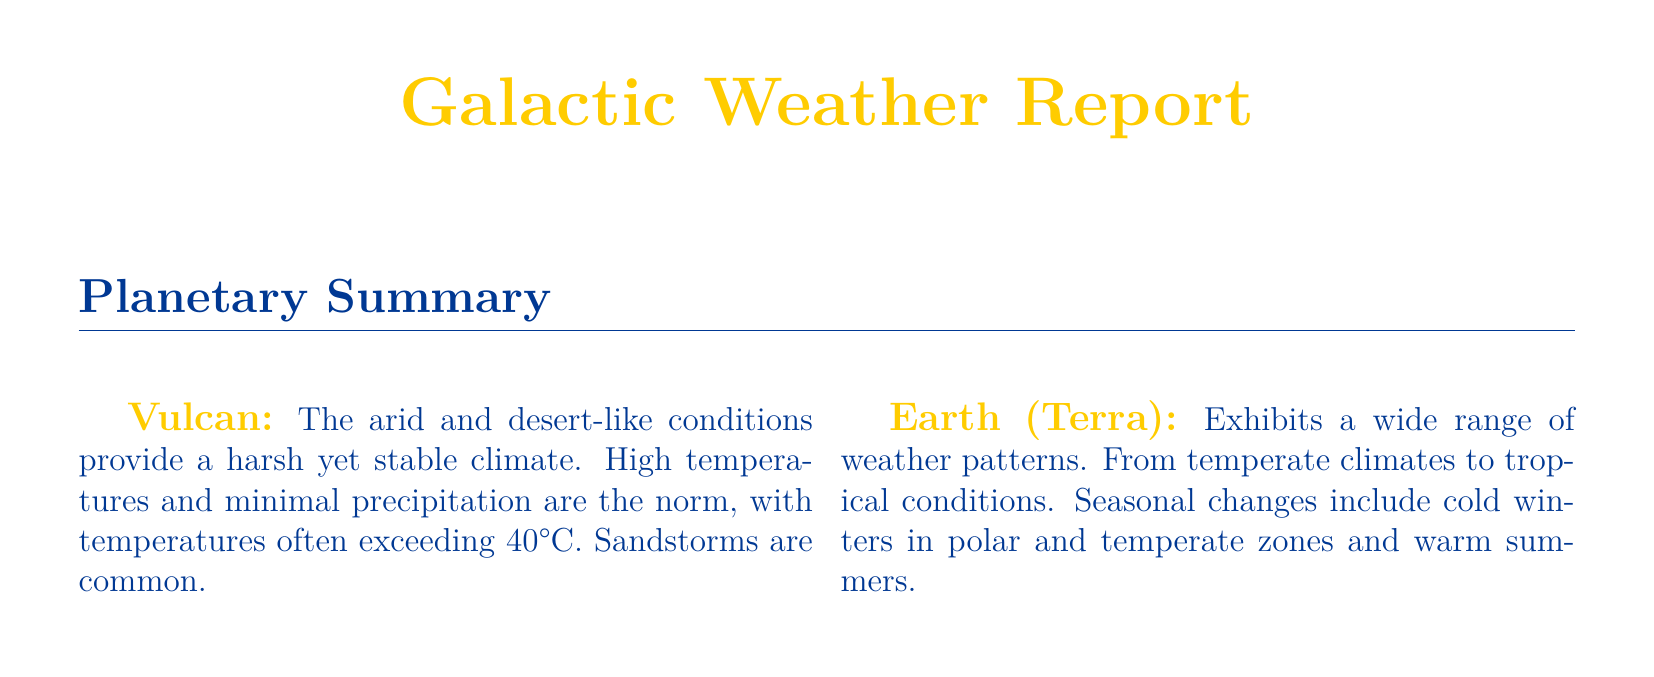What are the current temperatures on Vulcan? The current temperature on Vulcan is listed in the report, showing 42°C.
Answer: 42°C What weather conditions are expected on Andoria? The forecast for Andoria indicates persistent blizzards and freezing temperatures.
Answer: Blizzards What kind of storms are common on Vulcan? The document specifies that sandstorms are common in Vulcan's climate.
Answer: Sandstorms Which planet has heavy snow as a current condition? The current conditions for Andoria indicate heavy snow.
Answer: Andoria What is the maximum wind speed forecasted for Delta Vega? Delta Vega's report shows wind conditions of 100+ km/h.
Answer: 100+ km/h What type of climate does Cestus III have? The report describes Cestus III as having a semi-arid climate with moderate seasons.
Answer: Semi-arid What are the expected weather changes on Earth? The forecast for Earth highlights cooler weather and increased rainfall in tropical regions.
Answer: Cooler weather What is the temperature range on Earth? The current temperature on Earth is stated as ranging from 15-30°C.
Answer: 15-30°C What is the precipitation condition on Vulcan? The report indicates there is no precipitation expected on Vulcan.
Answer: None 